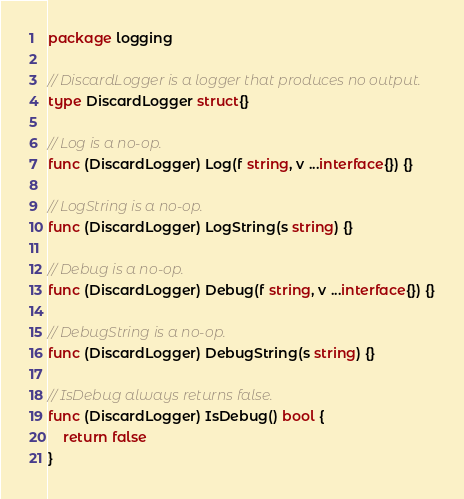<code> <loc_0><loc_0><loc_500><loc_500><_Go_>package logging

// DiscardLogger is a logger that produces no output.
type DiscardLogger struct{}

// Log is a no-op.
func (DiscardLogger) Log(f string, v ...interface{}) {}

// LogString is a no-op.
func (DiscardLogger) LogString(s string) {}

// Debug is a no-op.
func (DiscardLogger) Debug(f string, v ...interface{}) {}

// DebugString is a no-op.
func (DiscardLogger) DebugString(s string) {}

// IsDebug always returns false.
func (DiscardLogger) IsDebug() bool {
	return false
}
</code> 